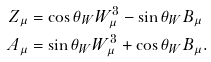Convert formula to latex. <formula><loc_0><loc_0><loc_500><loc_500>Z _ { \mu } & = \cos \theta _ { W } W ^ { 3 } _ { \mu } - \sin \theta _ { W } B _ { \mu } \\ A _ { \mu } & = \sin \theta _ { W } W ^ { 3 } _ { \mu } + \cos \theta _ { W } B _ { \mu } .</formula> 